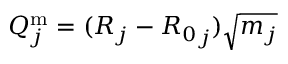<formula> <loc_0><loc_0><loc_500><loc_500>Q _ { j } ^ { m } = ( R _ { j } - { R _ { 0 } } _ { j } ) \sqrt { m _ { j } }</formula> 